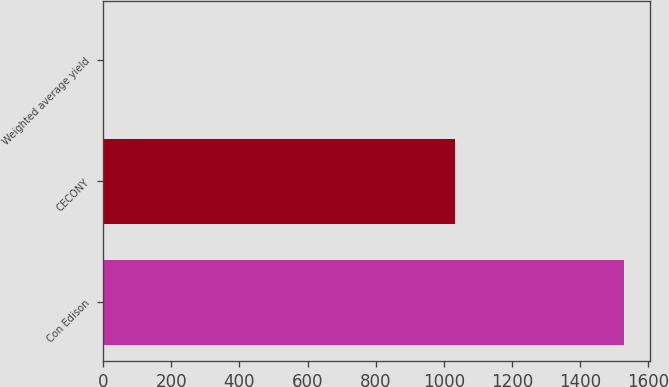Convert chart to OTSL. <chart><loc_0><loc_0><loc_500><loc_500><bar_chart><fcel>Con Edison<fcel>CECONY<fcel>Weighted average yield<nl><fcel>1529<fcel>1033<fcel>0.7<nl></chart> 